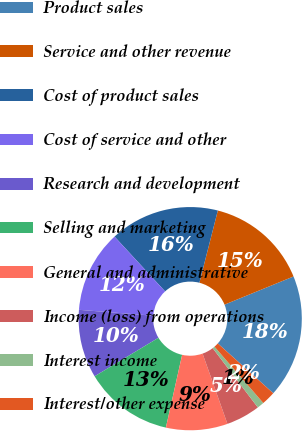<chart> <loc_0><loc_0><loc_500><loc_500><pie_chart><fcel>Product sales<fcel>Service and other revenue<fcel>Cost of product sales<fcel>Cost of service and other<fcel>Research and development<fcel>Selling and marketing<fcel>General and administrative<fcel>Income (loss) from operations<fcel>Interest income<fcel>Interest/other expense<nl><fcel>17.82%<fcel>14.85%<fcel>15.84%<fcel>11.88%<fcel>9.9%<fcel>12.87%<fcel>8.91%<fcel>4.95%<fcel>1.0%<fcel>1.99%<nl></chart> 